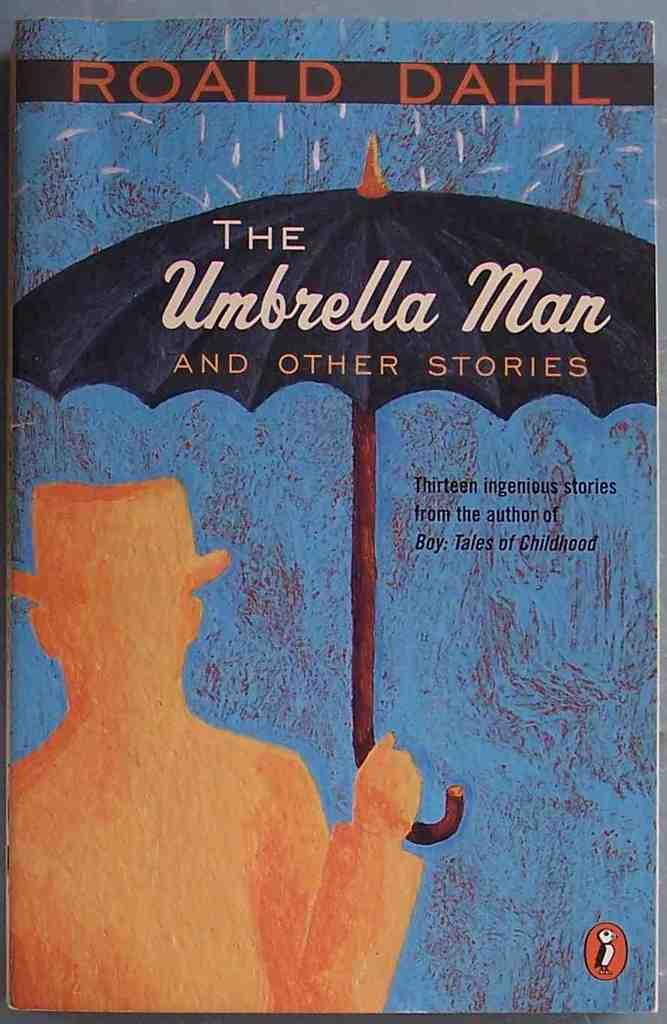<image>
Summarize the visual content of the image. A book titled the Umbrella Man by Ronald Dahl. 